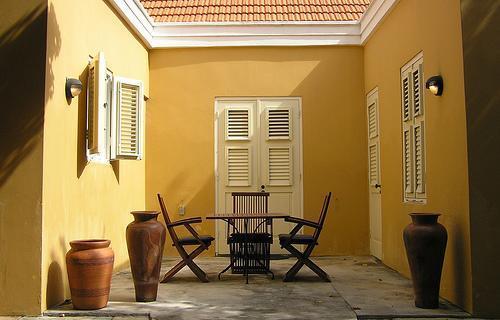How many chairs does the table have?
Give a very brief answer. 3. How many vases are similar?
Give a very brief answer. 2. 